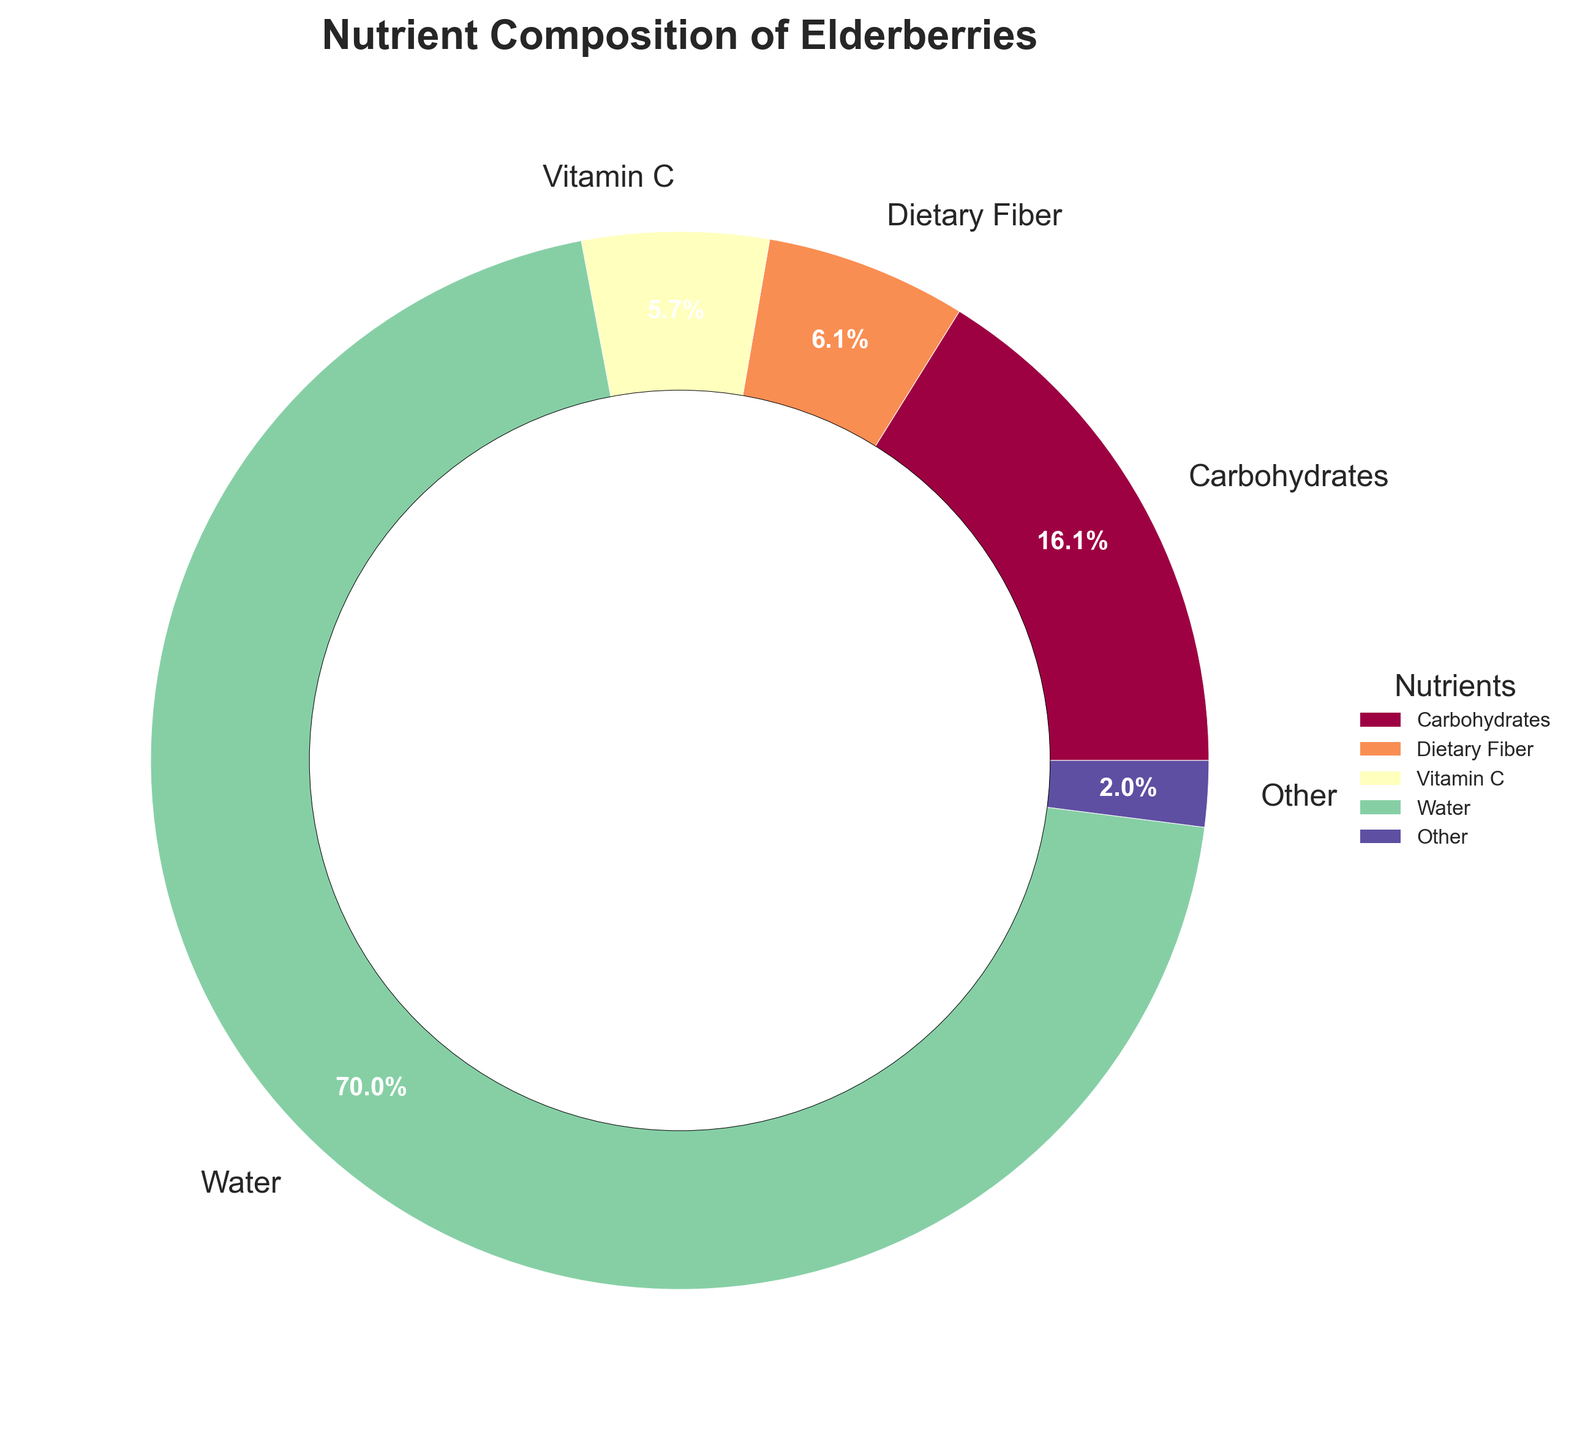What's the largest nutrient component in elderberries? The largest component can be identified by looking for the slice with the biggest area on the pie chart, which also has the highest percentage label.
Answer: Water What's the sum of the percentages of Carbohydrates and Dietary Fiber? Find the percentages for Carbohydrates (18.4%) and Dietary Fiber (7.0%), then add them together: 18.4 + 7.0 = 25.4
Answer: 25.4% Which nutrient has a higher percentage, Vitamin C or Protein? Locate the slices for Vitamin C (6.5%) and Protein (0.7%) on the pie chart, and compare their values to see which one is higher.
Answer: Vitamin C What is the combined percentage of nutrients other than Water? Water takes 79.8% of the chart, and the total sum of all components is 100%, so 100% - 79.8% = 20.2%.
Answer: 20.2% What color represents Vitamin C on the pie chart? Identify the segment labeled Vitamin C and describe the color used to fill it by observing the chart.
Answer: (This answer depends on the exact output which isn't specified, if not known state "Refer to the visual chart") How does the percentage of Protein compare to the percentage labeled as 'Other'? Protein is 0.7%. 'Other' is the sum of all segments below 1%: Fat (0.5%), Vitamin B6 (0.3%), Calcium (0.3%), Iron (0.2%), Potassium (0.2%), and Vitamin A (0.1%), which sums up to 1.6%. Thus, 0.7% < 1.6%.
Answer: Protein is less than 'Other' If you were to group all vitamins (A, B6, and C), what would their total percentage be? Adding Vitamin A (0.1%), Vitamin B6 (0.3%), and Vitamin C (6.5%): 0.1 + 0.3 + 6.5 = 6.9
Answer: 6.9% Which nutrient occupies the smallest segment in the pie chart? The smallest segment will have the smallest percentage value. By observing, Vitamin A (0.1%) is the smallest.
Answer: Vitamin A What percentage of elderberries is comprised of non-nutritional elements (like water)? The non-nutritional component in this context is Water, which is 79.8%. This is a standalone value directly from the chart.
Answer: 79.8% 